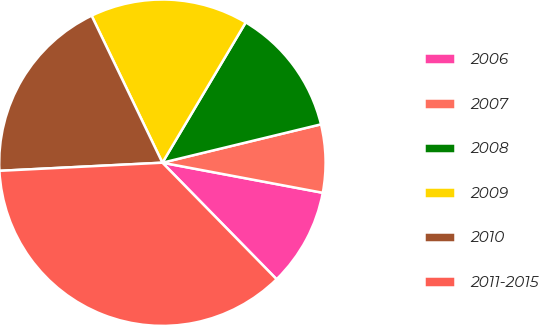Convert chart. <chart><loc_0><loc_0><loc_500><loc_500><pie_chart><fcel>2006<fcel>2007<fcel>2008<fcel>2009<fcel>2010<fcel>2011-2015<nl><fcel>9.71%<fcel>6.73%<fcel>12.69%<fcel>15.67%<fcel>18.65%<fcel>36.54%<nl></chart> 